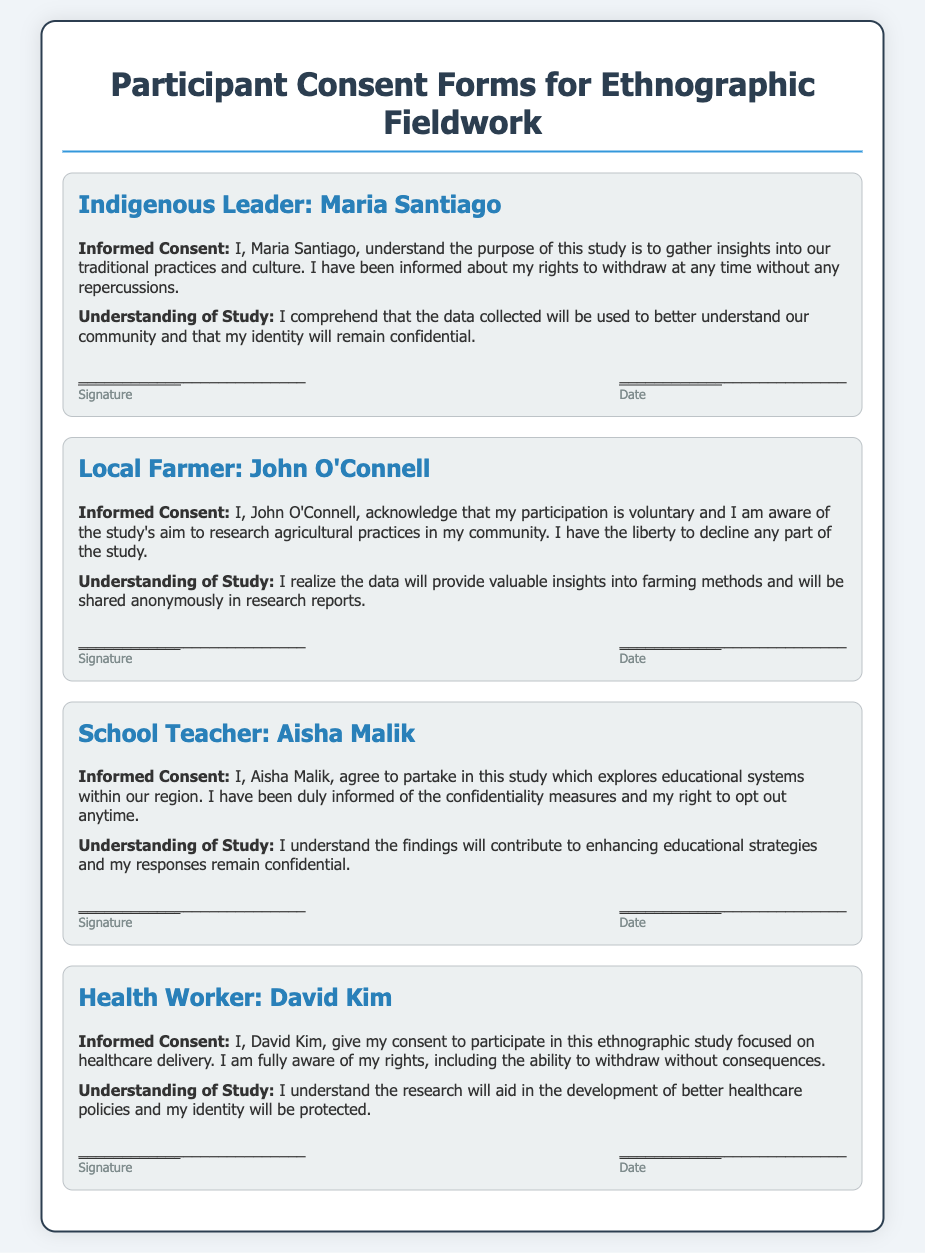What is the name of the Indigenous leader? The document lists the Indigenous leader as Maria Santiago.
Answer: Maria Santiago Who is the local farmer participating in the study? The document mentions John O'Connell as the local farmer involved in the study.
Answer: John O'Connell What is the main focus of David Kim's research study? The study David Kim is participating in is focused on healthcare delivery.
Answer: Healthcare delivery How many consent forms are included in the document? The document contains four consent forms for different participants.
Answer: Four What rights are mentioned regarding participation in the study? The document states that participants have the right to withdraw at any time without repercussions.
Answer: Withdraw at any time What is the primary aim of Aisha Malik's study participation? Aisha Malik's study aims to explore educational systems within the region.
Answer: Educational systems Which participant acknowledged the study’s aim related to agricultural practices? The consent form of John O'Connell indicates acknowledgment of this aim.
Answer: John O'Connell What confidentiality measure is mentioned in the consent forms? The document indicates that participants' identities will remain confidential.
Answer: Confidentiality 